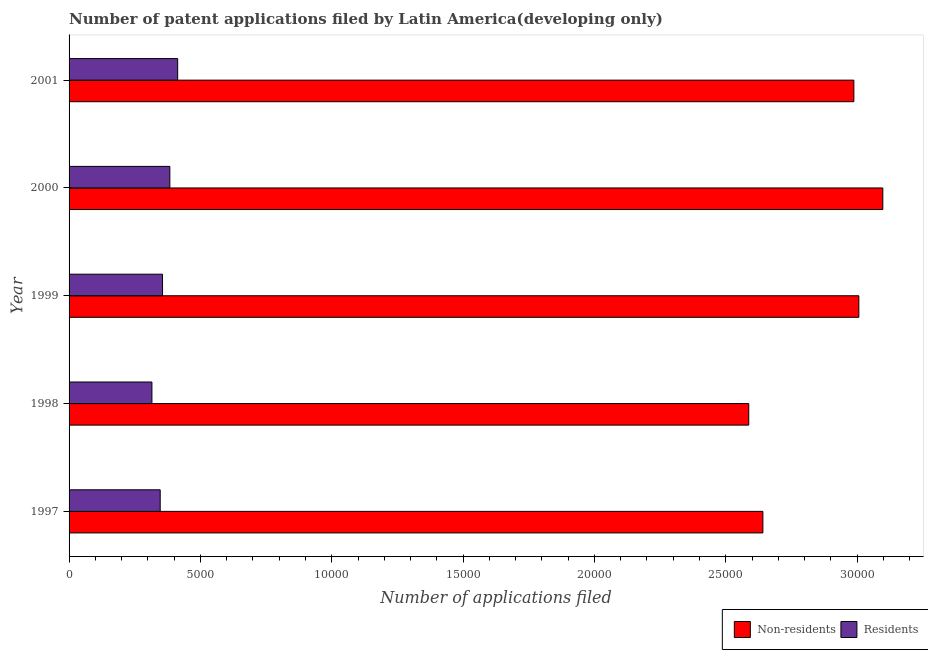How many different coloured bars are there?
Your response must be concise. 2. How many groups of bars are there?
Your answer should be very brief. 5. Are the number of bars per tick equal to the number of legend labels?
Keep it short and to the point. Yes. Are the number of bars on each tick of the Y-axis equal?
Keep it short and to the point. Yes. What is the label of the 1st group of bars from the top?
Give a very brief answer. 2001. In how many cases, is the number of bars for a given year not equal to the number of legend labels?
Give a very brief answer. 0. What is the number of patent applications by residents in 1998?
Your answer should be very brief. 3154. Across all years, what is the maximum number of patent applications by residents?
Ensure brevity in your answer.  4134. Across all years, what is the minimum number of patent applications by residents?
Your answer should be compact. 3154. In which year was the number of patent applications by residents maximum?
Make the answer very short. 2001. What is the total number of patent applications by residents in the graph?
Provide a succinct answer. 1.82e+04. What is the difference between the number of patent applications by non residents in 1997 and that in 2001?
Give a very brief answer. -3463. What is the difference between the number of patent applications by non residents in 2000 and the number of patent applications by residents in 2001?
Give a very brief answer. 2.68e+04. What is the average number of patent applications by non residents per year?
Offer a very short reply. 2.86e+04. In the year 2000, what is the difference between the number of patent applications by non residents and number of patent applications by residents?
Keep it short and to the point. 2.71e+04. Is the difference between the number of patent applications by non residents in 1997 and 1999 greater than the difference between the number of patent applications by residents in 1997 and 1999?
Provide a succinct answer. No. What is the difference between the highest and the second highest number of patent applications by non residents?
Keep it short and to the point. 912. What is the difference between the highest and the lowest number of patent applications by residents?
Offer a terse response. 980. In how many years, is the number of patent applications by residents greater than the average number of patent applications by residents taken over all years?
Offer a very short reply. 2. Is the sum of the number of patent applications by residents in 1999 and 2001 greater than the maximum number of patent applications by non residents across all years?
Ensure brevity in your answer.  No. What does the 2nd bar from the top in 2000 represents?
Ensure brevity in your answer.  Non-residents. What does the 1st bar from the bottom in 1997 represents?
Make the answer very short. Non-residents. How many bars are there?
Provide a succinct answer. 10. Are the values on the major ticks of X-axis written in scientific E-notation?
Your response must be concise. No. Does the graph contain any zero values?
Give a very brief answer. No. How many legend labels are there?
Offer a terse response. 2. What is the title of the graph?
Provide a succinct answer. Number of patent applications filed by Latin America(developing only). Does "All education staff compensation" appear as one of the legend labels in the graph?
Provide a succinct answer. No. What is the label or title of the X-axis?
Your response must be concise. Number of applications filed. What is the label or title of the Y-axis?
Ensure brevity in your answer.  Year. What is the Number of applications filed in Non-residents in 1997?
Give a very brief answer. 2.64e+04. What is the Number of applications filed in Residents in 1997?
Offer a terse response. 3469. What is the Number of applications filed in Non-residents in 1998?
Keep it short and to the point. 2.59e+04. What is the Number of applications filed of Residents in 1998?
Provide a short and direct response. 3154. What is the Number of applications filed in Non-residents in 1999?
Your answer should be compact. 3.01e+04. What is the Number of applications filed of Residents in 1999?
Ensure brevity in your answer.  3558. What is the Number of applications filed in Non-residents in 2000?
Offer a terse response. 3.10e+04. What is the Number of applications filed in Residents in 2000?
Your answer should be very brief. 3836. What is the Number of applications filed in Non-residents in 2001?
Make the answer very short. 2.99e+04. What is the Number of applications filed in Residents in 2001?
Offer a terse response. 4134. Across all years, what is the maximum Number of applications filed in Non-residents?
Ensure brevity in your answer.  3.10e+04. Across all years, what is the maximum Number of applications filed of Residents?
Make the answer very short. 4134. Across all years, what is the minimum Number of applications filed in Non-residents?
Give a very brief answer. 2.59e+04. Across all years, what is the minimum Number of applications filed in Residents?
Provide a succinct answer. 3154. What is the total Number of applications filed of Non-residents in the graph?
Offer a very short reply. 1.43e+05. What is the total Number of applications filed in Residents in the graph?
Ensure brevity in your answer.  1.82e+04. What is the difference between the Number of applications filed of Non-residents in 1997 and that in 1998?
Your response must be concise. 538. What is the difference between the Number of applications filed in Residents in 1997 and that in 1998?
Keep it short and to the point. 315. What is the difference between the Number of applications filed in Non-residents in 1997 and that in 1999?
Your response must be concise. -3653. What is the difference between the Number of applications filed in Residents in 1997 and that in 1999?
Provide a short and direct response. -89. What is the difference between the Number of applications filed of Non-residents in 1997 and that in 2000?
Offer a very short reply. -4565. What is the difference between the Number of applications filed of Residents in 1997 and that in 2000?
Your answer should be compact. -367. What is the difference between the Number of applications filed of Non-residents in 1997 and that in 2001?
Your answer should be very brief. -3463. What is the difference between the Number of applications filed in Residents in 1997 and that in 2001?
Make the answer very short. -665. What is the difference between the Number of applications filed in Non-residents in 1998 and that in 1999?
Your answer should be very brief. -4191. What is the difference between the Number of applications filed in Residents in 1998 and that in 1999?
Provide a short and direct response. -404. What is the difference between the Number of applications filed of Non-residents in 1998 and that in 2000?
Provide a succinct answer. -5103. What is the difference between the Number of applications filed in Residents in 1998 and that in 2000?
Give a very brief answer. -682. What is the difference between the Number of applications filed of Non-residents in 1998 and that in 2001?
Offer a terse response. -4001. What is the difference between the Number of applications filed of Residents in 1998 and that in 2001?
Give a very brief answer. -980. What is the difference between the Number of applications filed in Non-residents in 1999 and that in 2000?
Your answer should be compact. -912. What is the difference between the Number of applications filed of Residents in 1999 and that in 2000?
Offer a very short reply. -278. What is the difference between the Number of applications filed of Non-residents in 1999 and that in 2001?
Provide a succinct answer. 190. What is the difference between the Number of applications filed of Residents in 1999 and that in 2001?
Give a very brief answer. -576. What is the difference between the Number of applications filed of Non-residents in 2000 and that in 2001?
Keep it short and to the point. 1102. What is the difference between the Number of applications filed of Residents in 2000 and that in 2001?
Give a very brief answer. -298. What is the difference between the Number of applications filed in Non-residents in 1997 and the Number of applications filed in Residents in 1998?
Give a very brief answer. 2.33e+04. What is the difference between the Number of applications filed in Non-residents in 1997 and the Number of applications filed in Residents in 1999?
Give a very brief answer. 2.29e+04. What is the difference between the Number of applications filed in Non-residents in 1997 and the Number of applications filed in Residents in 2000?
Keep it short and to the point. 2.26e+04. What is the difference between the Number of applications filed in Non-residents in 1997 and the Number of applications filed in Residents in 2001?
Offer a very short reply. 2.23e+04. What is the difference between the Number of applications filed in Non-residents in 1998 and the Number of applications filed in Residents in 1999?
Ensure brevity in your answer.  2.23e+04. What is the difference between the Number of applications filed in Non-residents in 1998 and the Number of applications filed in Residents in 2000?
Your answer should be very brief. 2.20e+04. What is the difference between the Number of applications filed in Non-residents in 1998 and the Number of applications filed in Residents in 2001?
Ensure brevity in your answer.  2.17e+04. What is the difference between the Number of applications filed in Non-residents in 1999 and the Number of applications filed in Residents in 2000?
Make the answer very short. 2.62e+04. What is the difference between the Number of applications filed in Non-residents in 1999 and the Number of applications filed in Residents in 2001?
Offer a terse response. 2.59e+04. What is the difference between the Number of applications filed in Non-residents in 2000 and the Number of applications filed in Residents in 2001?
Ensure brevity in your answer.  2.68e+04. What is the average Number of applications filed in Non-residents per year?
Offer a very short reply. 2.86e+04. What is the average Number of applications filed in Residents per year?
Offer a very short reply. 3630.2. In the year 1997, what is the difference between the Number of applications filed of Non-residents and Number of applications filed of Residents?
Provide a succinct answer. 2.29e+04. In the year 1998, what is the difference between the Number of applications filed in Non-residents and Number of applications filed in Residents?
Your response must be concise. 2.27e+04. In the year 1999, what is the difference between the Number of applications filed of Non-residents and Number of applications filed of Residents?
Ensure brevity in your answer.  2.65e+04. In the year 2000, what is the difference between the Number of applications filed of Non-residents and Number of applications filed of Residents?
Ensure brevity in your answer.  2.71e+04. In the year 2001, what is the difference between the Number of applications filed of Non-residents and Number of applications filed of Residents?
Keep it short and to the point. 2.57e+04. What is the ratio of the Number of applications filed in Non-residents in 1997 to that in 1998?
Offer a terse response. 1.02. What is the ratio of the Number of applications filed of Residents in 1997 to that in 1998?
Keep it short and to the point. 1.1. What is the ratio of the Number of applications filed in Non-residents in 1997 to that in 1999?
Your answer should be very brief. 0.88. What is the ratio of the Number of applications filed in Residents in 1997 to that in 1999?
Give a very brief answer. 0.97. What is the ratio of the Number of applications filed of Non-residents in 1997 to that in 2000?
Your response must be concise. 0.85. What is the ratio of the Number of applications filed of Residents in 1997 to that in 2000?
Keep it short and to the point. 0.9. What is the ratio of the Number of applications filed in Non-residents in 1997 to that in 2001?
Your answer should be very brief. 0.88. What is the ratio of the Number of applications filed of Residents in 1997 to that in 2001?
Make the answer very short. 0.84. What is the ratio of the Number of applications filed of Non-residents in 1998 to that in 1999?
Your answer should be compact. 0.86. What is the ratio of the Number of applications filed in Residents in 1998 to that in 1999?
Make the answer very short. 0.89. What is the ratio of the Number of applications filed of Non-residents in 1998 to that in 2000?
Ensure brevity in your answer.  0.84. What is the ratio of the Number of applications filed in Residents in 1998 to that in 2000?
Your answer should be very brief. 0.82. What is the ratio of the Number of applications filed of Non-residents in 1998 to that in 2001?
Ensure brevity in your answer.  0.87. What is the ratio of the Number of applications filed in Residents in 1998 to that in 2001?
Give a very brief answer. 0.76. What is the ratio of the Number of applications filed of Non-residents in 1999 to that in 2000?
Keep it short and to the point. 0.97. What is the ratio of the Number of applications filed in Residents in 1999 to that in 2000?
Your response must be concise. 0.93. What is the ratio of the Number of applications filed in Non-residents in 1999 to that in 2001?
Give a very brief answer. 1.01. What is the ratio of the Number of applications filed of Residents in 1999 to that in 2001?
Your response must be concise. 0.86. What is the ratio of the Number of applications filed of Non-residents in 2000 to that in 2001?
Your answer should be very brief. 1.04. What is the ratio of the Number of applications filed in Residents in 2000 to that in 2001?
Keep it short and to the point. 0.93. What is the difference between the highest and the second highest Number of applications filed of Non-residents?
Keep it short and to the point. 912. What is the difference between the highest and the second highest Number of applications filed in Residents?
Give a very brief answer. 298. What is the difference between the highest and the lowest Number of applications filed of Non-residents?
Provide a succinct answer. 5103. What is the difference between the highest and the lowest Number of applications filed of Residents?
Offer a terse response. 980. 